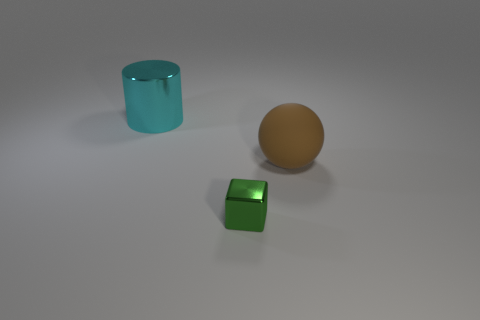What might be the function of these objects, and do they look like they belong to the same set? The objects do not appear to serve any obvious function and seem purely decorative. While they differ in shape and color, their similar minimalistic style and the material finish suggest they could belong to a set used for artistic or display purposes. 